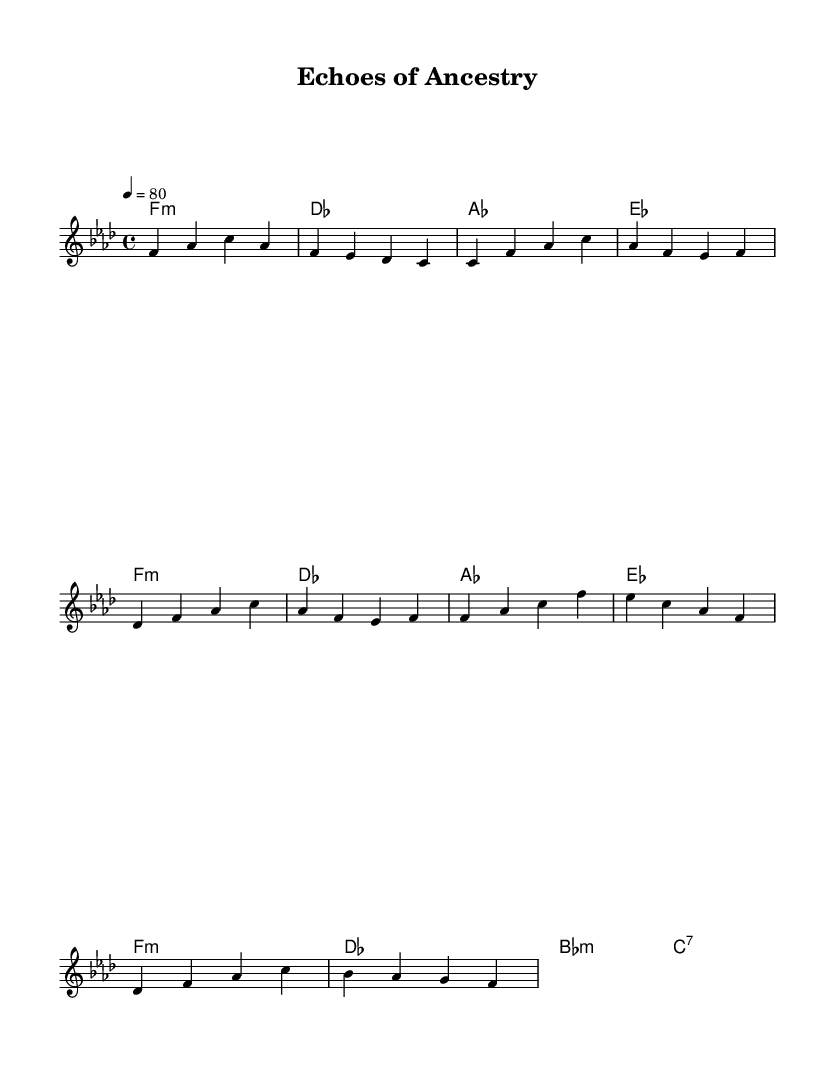What is the key signature of this music? The key signature is indicated by the flats placed at the beginning of the staff. In this case, there are four flats, which corresponds to the key of F minor.
Answer: F minor What is the time signature of this music? The time signature appears at the beginning of the piece, shown as 4/4. This indicates that there are four beats per measure, and a quarter note gets one beat.
Answer: 4/4 What is the tempo marking of this music? The tempo is specified above the staff as 4 = 80, which means that the quarter note is to be played at a speed of 80 beats per minute.
Answer: 80 What is the first chord played in the introduction? The first chord is listed in the harmonies section on the first beat of the introduction, which is f minor.
Answer: f minor How many measures are there in the chorus of this piece? The chorus consists of four measures, as indicated by the grouping of notes and rests in the chord and melody sections. Each measure is clearly defined by the vertical bar lines.
Answer: 4 What is the final chord in the melody? The final note aligns with a chord that is labeled at the end of the melody, which is f. This is also the last note played in the score.
Answer: f What theme is explored in the song? The title, "Echoes of Ancestry," suggests that the song's theme revolves around cultural heritage, particularly in the context of the African diaspora. This is reflected in contemporary R&B's focus on expressing such themes.
Answer: Cultural heritage 